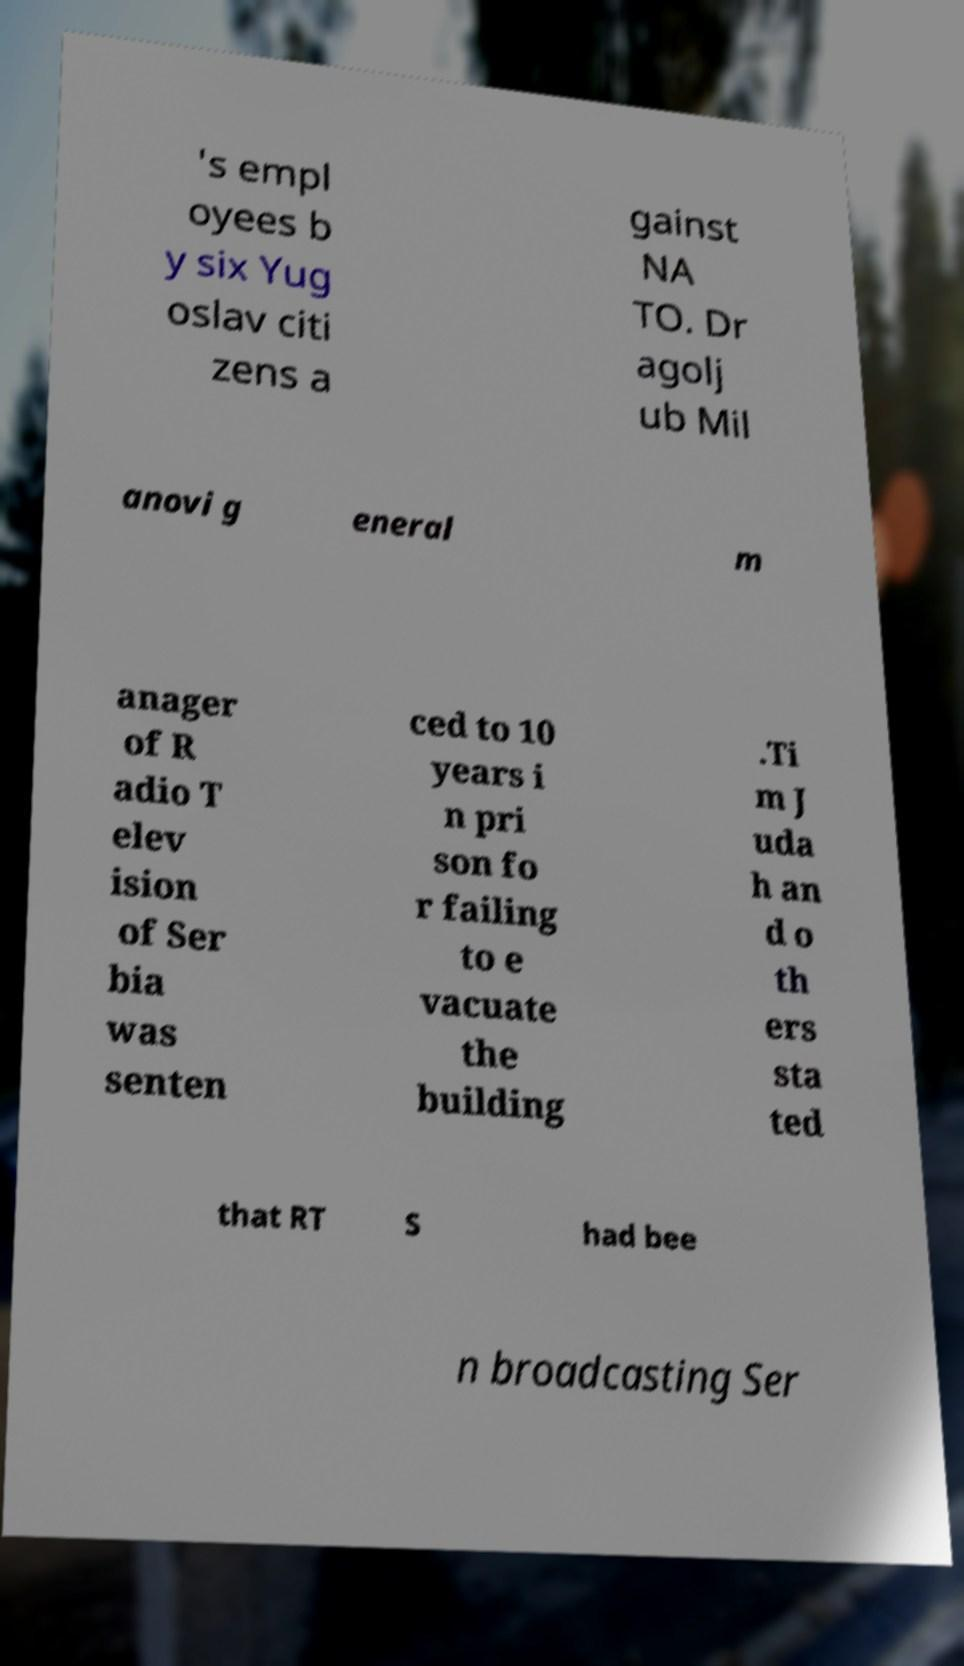There's text embedded in this image that I need extracted. Can you transcribe it verbatim? 's empl oyees b y six Yug oslav citi zens a gainst NA TO. Dr agolj ub Mil anovi g eneral m anager of R adio T elev ision of Ser bia was senten ced to 10 years i n pri son fo r failing to e vacuate the building .Ti m J uda h an d o th ers sta ted that RT S had bee n broadcasting Ser 